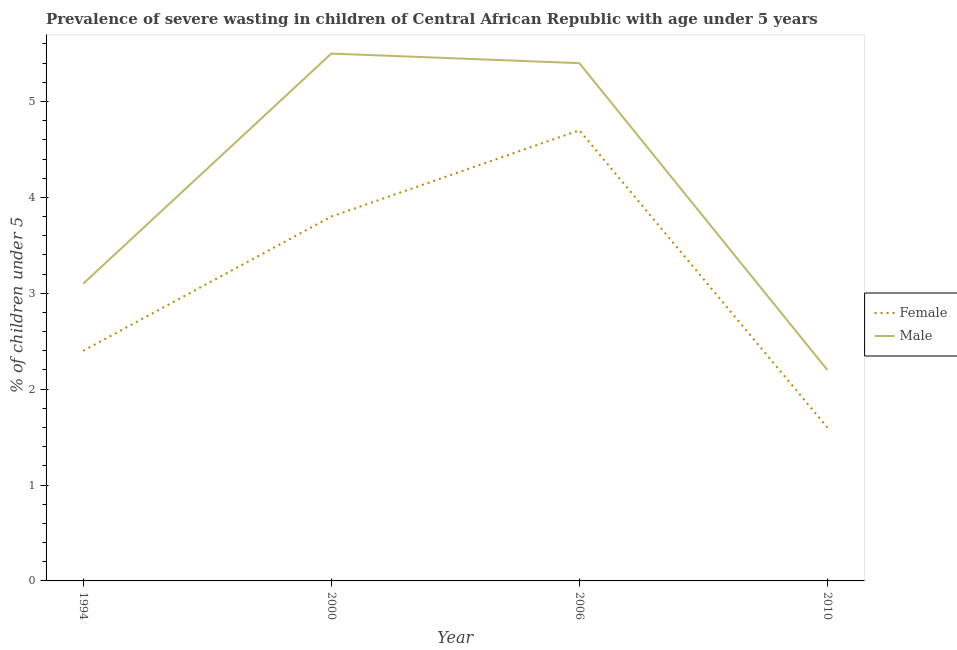How many different coloured lines are there?
Give a very brief answer. 2. Is the number of lines equal to the number of legend labels?
Your answer should be compact. Yes. What is the percentage of undernourished female children in 2000?
Ensure brevity in your answer.  3.8. Across all years, what is the minimum percentage of undernourished male children?
Give a very brief answer. 2.2. In which year was the percentage of undernourished female children maximum?
Offer a terse response. 2006. In which year was the percentage of undernourished male children minimum?
Your answer should be compact. 2010. What is the total percentage of undernourished female children in the graph?
Provide a short and direct response. 12.5. What is the difference between the percentage of undernourished female children in 1994 and that in 2000?
Your answer should be compact. -1.4. What is the difference between the percentage of undernourished female children in 1994 and the percentage of undernourished male children in 2006?
Your answer should be compact. -3. What is the average percentage of undernourished female children per year?
Make the answer very short. 3.12. In the year 1994, what is the difference between the percentage of undernourished female children and percentage of undernourished male children?
Make the answer very short. -0.7. What is the ratio of the percentage of undernourished female children in 2006 to that in 2010?
Make the answer very short. 2.94. What is the difference between the highest and the second highest percentage of undernourished female children?
Give a very brief answer. 0.9. What is the difference between the highest and the lowest percentage of undernourished female children?
Your answer should be compact. 3.1. In how many years, is the percentage of undernourished female children greater than the average percentage of undernourished female children taken over all years?
Give a very brief answer. 2. Is the sum of the percentage of undernourished male children in 2000 and 2006 greater than the maximum percentage of undernourished female children across all years?
Ensure brevity in your answer.  Yes. Does the percentage of undernourished female children monotonically increase over the years?
Your answer should be very brief. No. How many years are there in the graph?
Give a very brief answer. 4. What is the difference between two consecutive major ticks on the Y-axis?
Offer a very short reply. 1. Are the values on the major ticks of Y-axis written in scientific E-notation?
Your response must be concise. No. Where does the legend appear in the graph?
Your answer should be compact. Center right. How are the legend labels stacked?
Offer a very short reply. Vertical. What is the title of the graph?
Make the answer very short. Prevalence of severe wasting in children of Central African Republic with age under 5 years. Does "Official creditors" appear as one of the legend labels in the graph?
Offer a very short reply. No. What is the label or title of the X-axis?
Provide a short and direct response. Year. What is the label or title of the Y-axis?
Provide a succinct answer.  % of children under 5. What is the  % of children under 5 in Female in 1994?
Your answer should be very brief. 2.4. What is the  % of children under 5 of Male in 1994?
Keep it short and to the point. 3.1. What is the  % of children under 5 in Female in 2000?
Offer a terse response. 3.8. What is the  % of children under 5 of Female in 2006?
Your response must be concise. 4.7. What is the  % of children under 5 in Male in 2006?
Make the answer very short. 5.4. What is the  % of children under 5 in Female in 2010?
Keep it short and to the point. 1.6. What is the  % of children under 5 of Male in 2010?
Provide a succinct answer. 2.2. Across all years, what is the maximum  % of children under 5 of Female?
Keep it short and to the point. 4.7. Across all years, what is the minimum  % of children under 5 of Female?
Your response must be concise. 1.6. Across all years, what is the minimum  % of children under 5 of Male?
Ensure brevity in your answer.  2.2. What is the total  % of children under 5 in Male in the graph?
Offer a very short reply. 16.2. What is the difference between the  % of children under 5 in Female in 1994 and that in 2006?
Provide a succinct answer. -2.3. What is the difference between the  % of children under 5 of Male in 1994 and that in 2006?
Your answer should be very brief. -2.3. What is the difference between the  % of children under 5 of Female in 1994 and that in 2010?
Make the answer very short. 0.8. What is the difference between the  % of children under 5 in Female in 2000 and that in 2006?
Your answer should be compact. -0.9. What is the difference between the  % of children under 5 of Male in 2000 and that in 2010?
Provide a succinct answer. 3.3. What is the difference between the  % of children under 5 of Female in 2006 and that in 2010?
Provide a short and direct response. 3.1. What is the difference between the  % of children under 5 in Male in 2006 and that in 2010?
Provide a short and direct response. 3.2. What is the difference between the  % of children under 5 of Female in 1994 and the  % of children under 5 of Male in 2000?
Offer a terse response. -3.1. What is the difference between the  % of children under 5 in Female in 1994 and the  % of children under 5 in Male in 2006?
Your answer should be compact. -3. What is the difference between the  % of children under 5 of Female in 2000 and the  % of children under 5 of Male in 2006?
Your answer should be very brief. -1.6. What is the difference between the  % of children under 5 in Female in 2000 and the  % of children under 5 in Male in 2010?
Give a very brief answer. 1.6. What is the difference between the  % of children under 5 in Female in 2006 and the  % of children under 5 in Male in 2010?
Keep it short and to the point. 2.5. What is the average  % of children under 5 of Female per year?
Keep it short and to the point. 3.12. What is the average  % of children under 5 of Male per year?
Make the answer very short. 4.05. In the year 1994, what is the difference between the  % of children under 5 of Female and  % of children under 5 of Male?
Your response must be concise. -0.7. In the year 2010, what is the difference between the  % of children under 5 in Female and  % of children under 5 in Male?
Give a very brief answer. -0.6. What is the ratio of the  % of children under 5 of Female in 1994 to that in 2000?
Give a very brief answer. 0.63. What is the ratio of the  % of children under 5 in Male in 1994 to that in 2000?
Ensure brevity in your answer.  0.56. What is the ratio of the  % of children under 5 of Female in 1994 to that in 2006?
Keep it short and to the point. 0.51. What is the ratio of the  % of children under 5 of Male in 1994 to that in 2006?
Provide a succinct answer. 0.57. What is the ratio of the  % of children under 5 in Male in 1994 to that in 2010?
Offer a terse response. 1.41. What is the ratio of the  % of children under 5 in Female in 2000 to that in 2006?
Make the answer very short. 0.81. What is the ratio of the  % of children under 5 of Male in 2000 to that in 2006?
Your response must be concise. 1.02. What is the ratio of the  % of children under 5 of Female in 2000 to that in 2010?
Give a very brief answer. 2.38. What is the ratio of the  % of children under 5 of Male in 2000 to that in 2010?
Make the answer very short. 2.5. What is the ratio of the  % of children under 5 of Female in 2006 to that in 2010?
Ensure brevity in your answer.  2.94. What is the ratio of the  % of children under 5 in Male in 2006 to that in 2010?
Your answer should be very brief. 2.45. What is the difference between the highest and the second highest  % of children under 5 of Female?
Give a very brief answer. 0.9. What is the difference between the highest and the lowest  % of children under 5 in Male?
Ensure brevity in your answer.  3.3. 